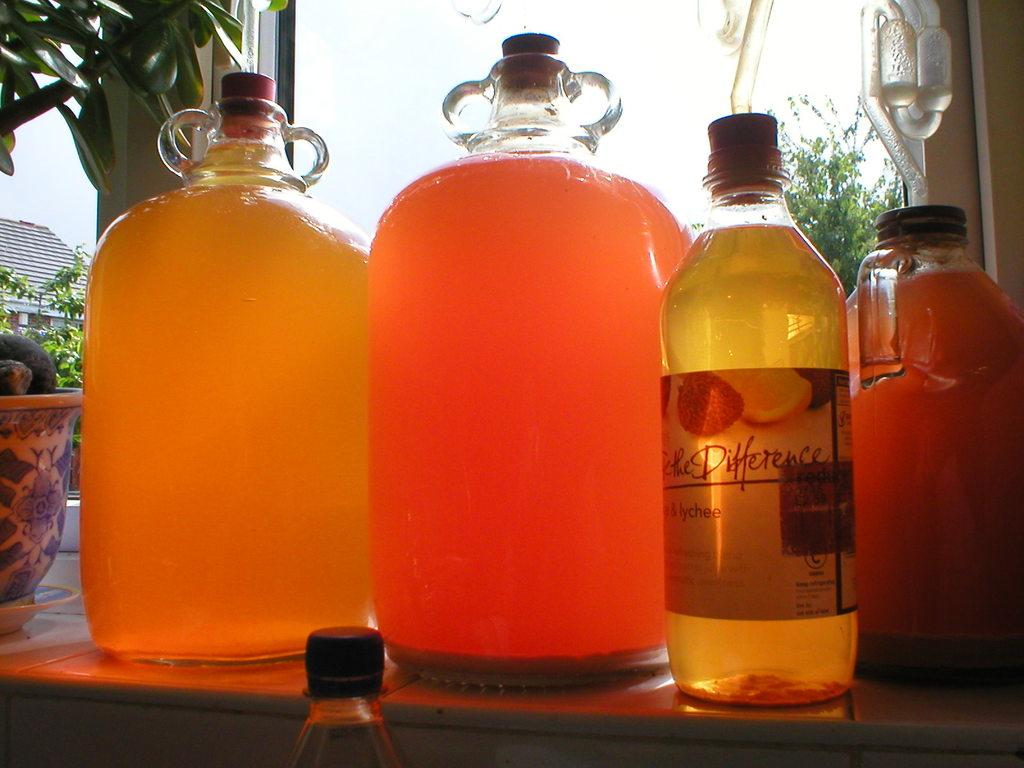<image>
Offer a succinct explanation of the picture presented. Four containers on a table one of which labeled DIfference. 